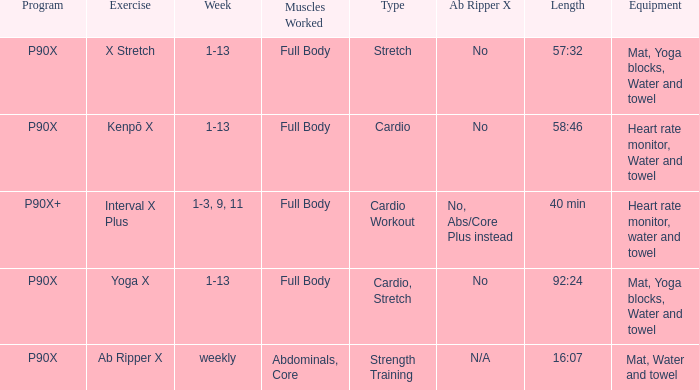What is the ab ripper x when the length is 92:24? No. 